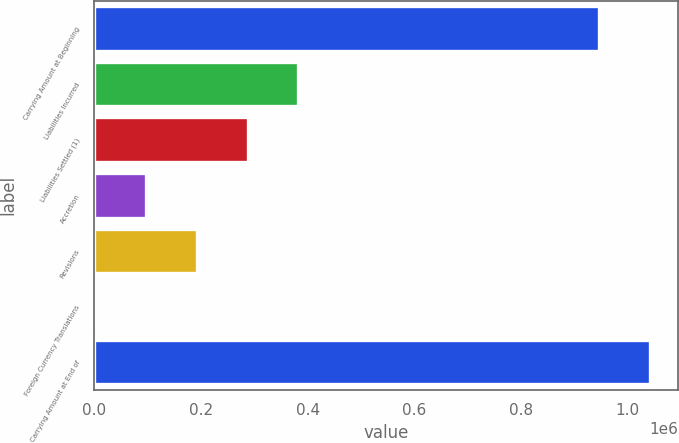Convert chart. <chart><loc_0><loc_0><loc_500><loc_500><bar_chart><fcel>Carrying Amount at Beginning<fcel>Liabilities Incurred<fcel>Liabilities Settled (1)<fcel>Accretion<fcel>Revisions<fcel>Foreign Currency Translations<fcel>Carrying Amount at End of<nl><fcel>946848<fcel>382717<fcel>287441<fcel>96887.6<fcel>192164<fcel>1611<fcel>1.04212e+06<nl></chart> 